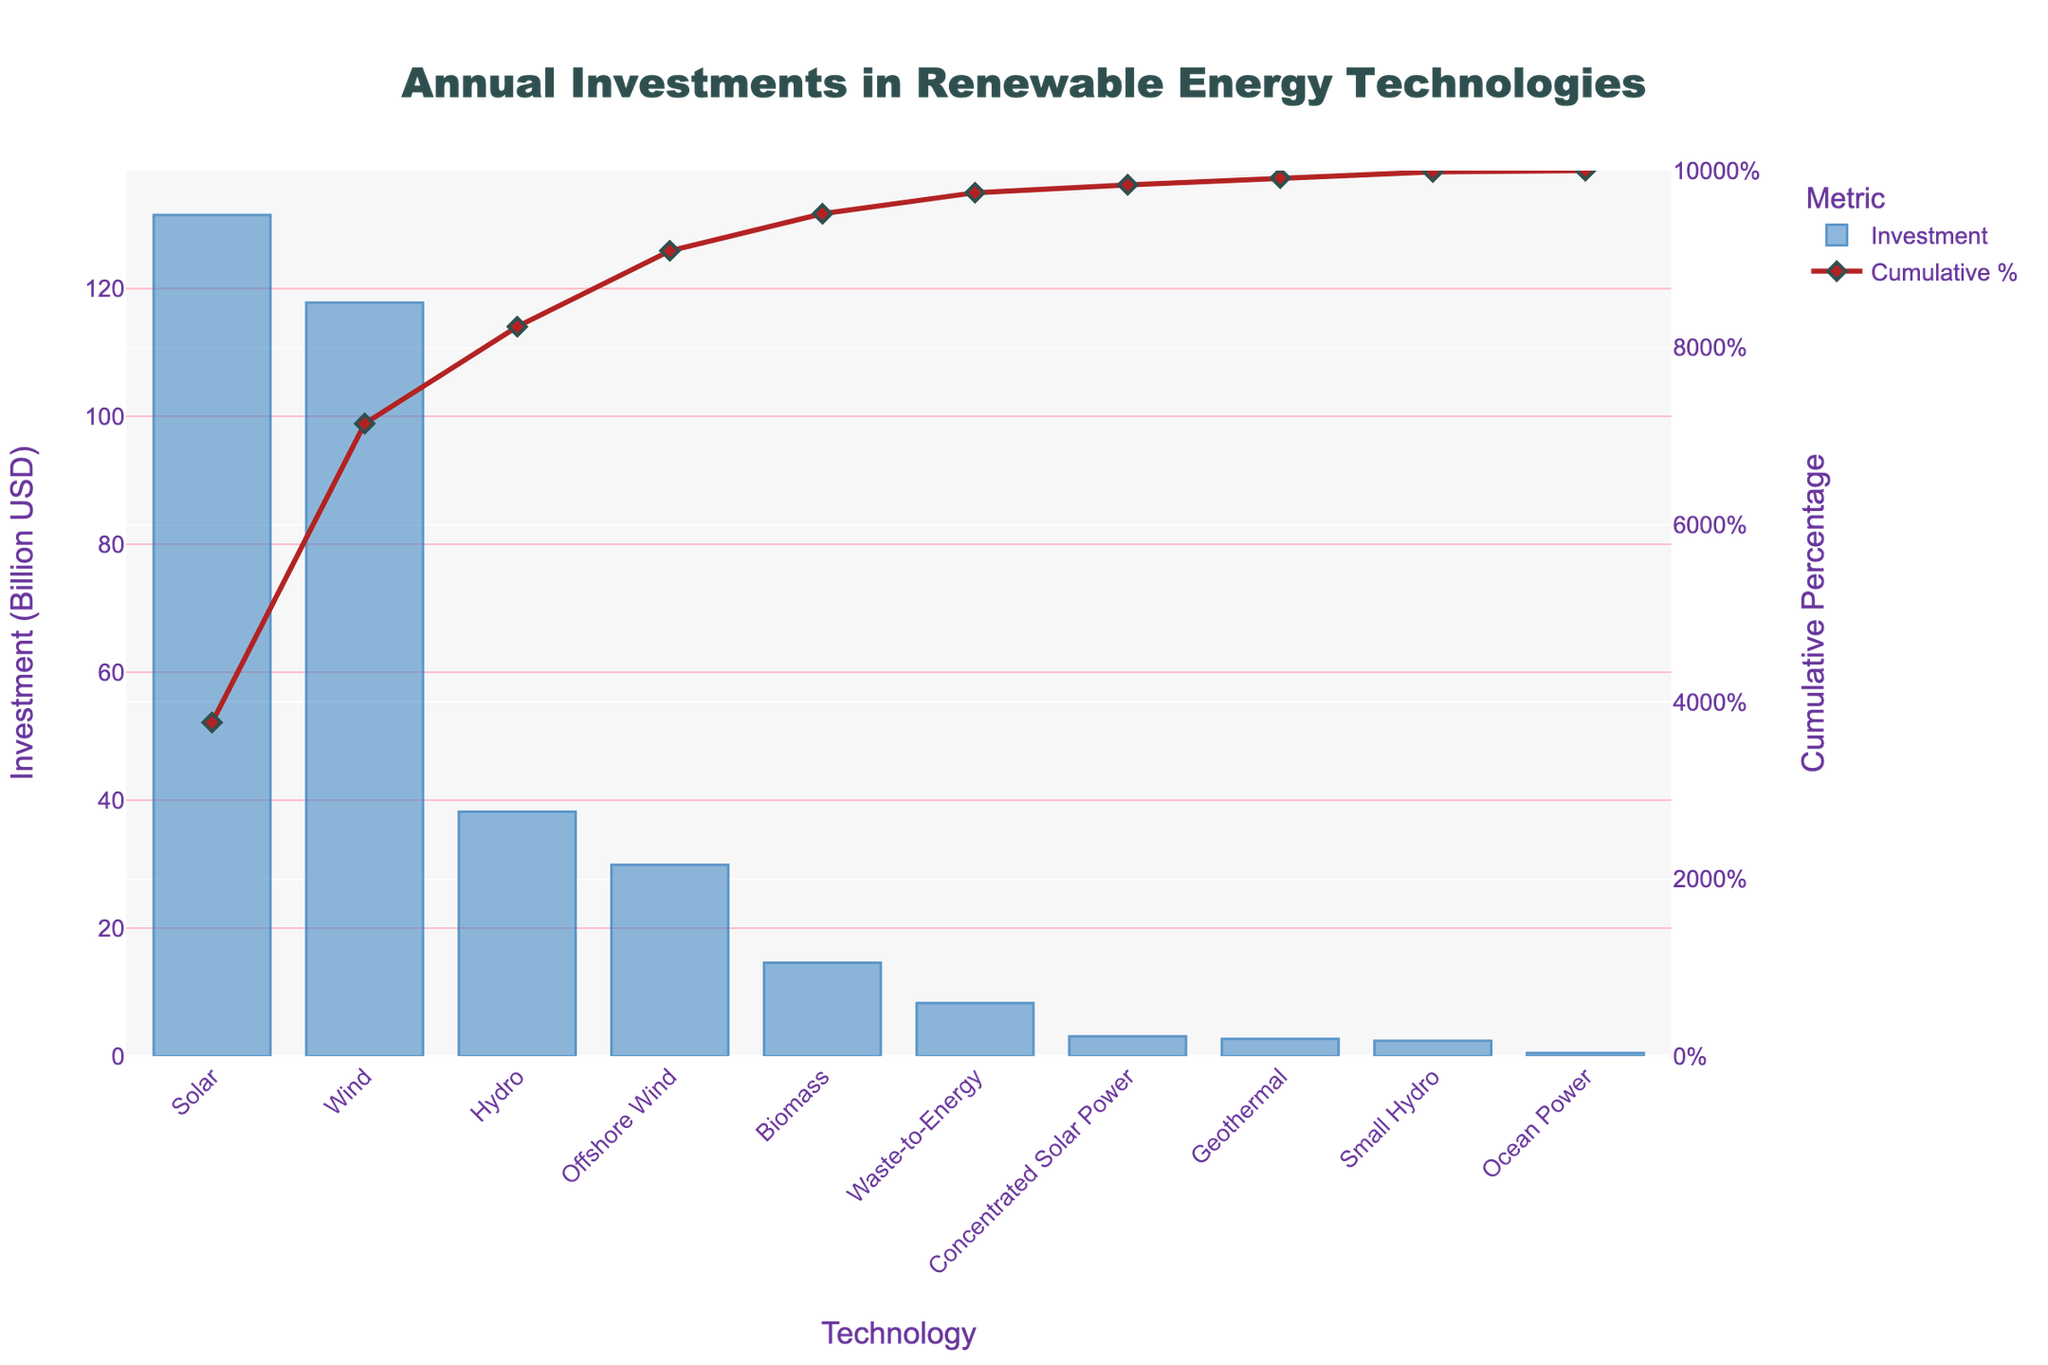What technology has the highest investment? From the chart, identify the bar with the greatest height. The tallest bar represents the technology with the highest investment, which is Solar.
Answer: Solar What is the combined investment for Solar and Wind technologies? Check the bar heights for Solar and Wind technologies, and sum their investments: Solar (131.5 Billion USD) + Wind (117.8 Billion USD).
Answer: 249.3 Billion USD Which technology has the lowest investment, and what is its value? Locate the shortest bar on the chart. The shortest bar represents Ocean Power, with an investment of 0.5 Billion USD.
Answer: Ocean Power, 0.5 Billion USD What is the difference in investment between Biomass and Geothermal? Identify the bars for Biomass and Geothermal. Subtract the investment of Geothermal (2.7 Billion USD) from Biomass (14.6 Billion USD).
Answer: 11.9 Billion USD What is the cumulative percentage investment up to Offshore Wind? Add the investments for technologies up to Offshore Wind and divide by the total investment, then multiply by 100. Technologies up to Offshore Wind: [131.5 (Solar) + 117.8 (Wind) + 38.2 (Hydro) + 29.9 (Offshore Wind)]. Total investment: 348 Billion USD. Cumulative percentage: (317.4 / 348) * 100.
Answer: 91.23% Which two technologies have the most similar investments and what are their investment values? Look for bars close in height. Wind (117.8 Billion USD) and Offshore Wind (29.9 Billion USD) are close but not the closest. Biomass (14.6 Billion USD) and Waste-to-Energy (8.3 Billion USD) are closer. Difference is smaller between Waste-to-Energy and Small Hydro, but Waste-to-Energy and Biomass are visually closer.
Answer: Biomass 14.6 Billion USD, Waste-to-Energy 8.3 Billion USD How many technologies have an investment greater than 10 Billion USD? Count the number of bars greater in height than the bar representing 10 Billion USD on the y-axis. The bars for Solar, Wind, Hydro, Biomass, and Offshore Wind all exceed 10 Billion USD.
Answer: 5 What is the average investment across all technologies? Sum all the investment amounts and divide by the number of technologies: (131.5 + 117.8 + 38.2 + 2.7 + 14.6 + 0.5 + 3.1 + 29.9 + 2.4 + 8.3) / 10.
Answer: 34.8 Billion USD What proportion of investment is in Solar compared to the total investment? Divide the Solar investment by the total investment and multiply by 100: (131.5 / 348) * 100.
Answer: 37.79% What technology has the second smallest investment and what is its value? Identify the second shortest bar after Ocean Power. The second shortest bar represents Small Hydro, which has an investment of 2.4 Billion USD.
Answer: Small Hydro, 2.4 Billion USD What is the visual characteristic of the cumulative percentage line? Describe the color and markers of the line: The line is red with diamond-shaped markers that are gray, and has a thickness that stands out against the bars.
Answer: Red line with diamond markers 